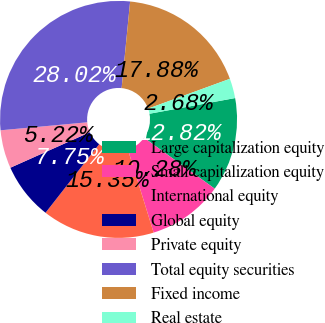Convert chart. <chart><loc_0><loc_0><loc_500><loc_500><pie_chart><fcel>Large capitalization equity<fcel>Small capitalization equity<fcel>International equity<fcel>Global equity<fcel>Private equity<fcel>Total equity securities<fcel>Fixed income<fcel>Real estate<nl><fcel>12.82%<fcel>10.28%<fcel>15.35%<fcel>7.75%<fcel>5.22%<fcel>28.02%<fcel>17.88%<fcel>2.68%<nl></chart> 